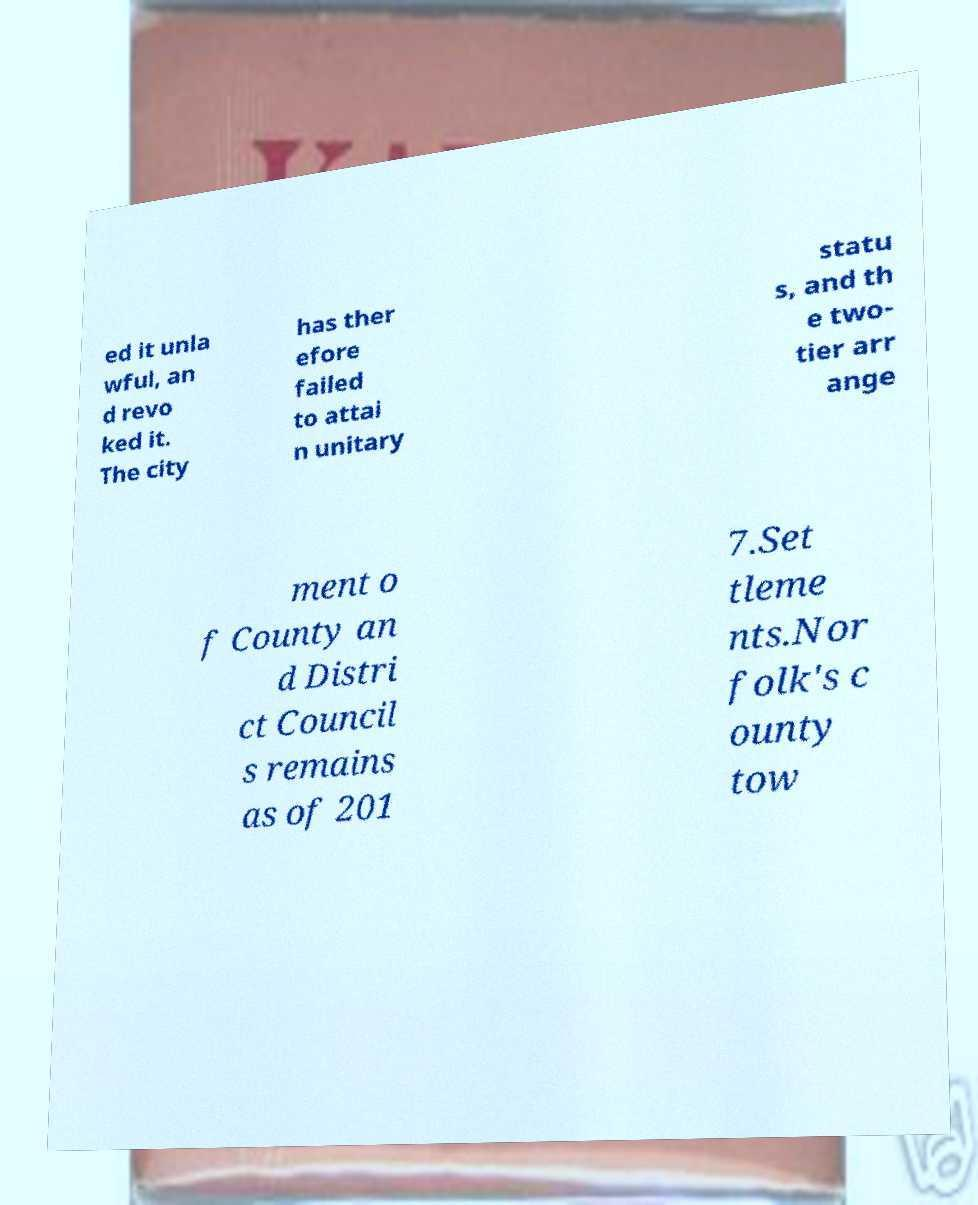There's text embedded in this image that I need extracted. Can you transcribe it verbatim? ed it unla wful, an d revo ked it. The city has ther efore failed to attai n unitary statu s, and th e two- tier arr ange ment o f County an d Distri ct Council s remains as of 201 7.Set tleme nts.Nor folk's c ounty tow 